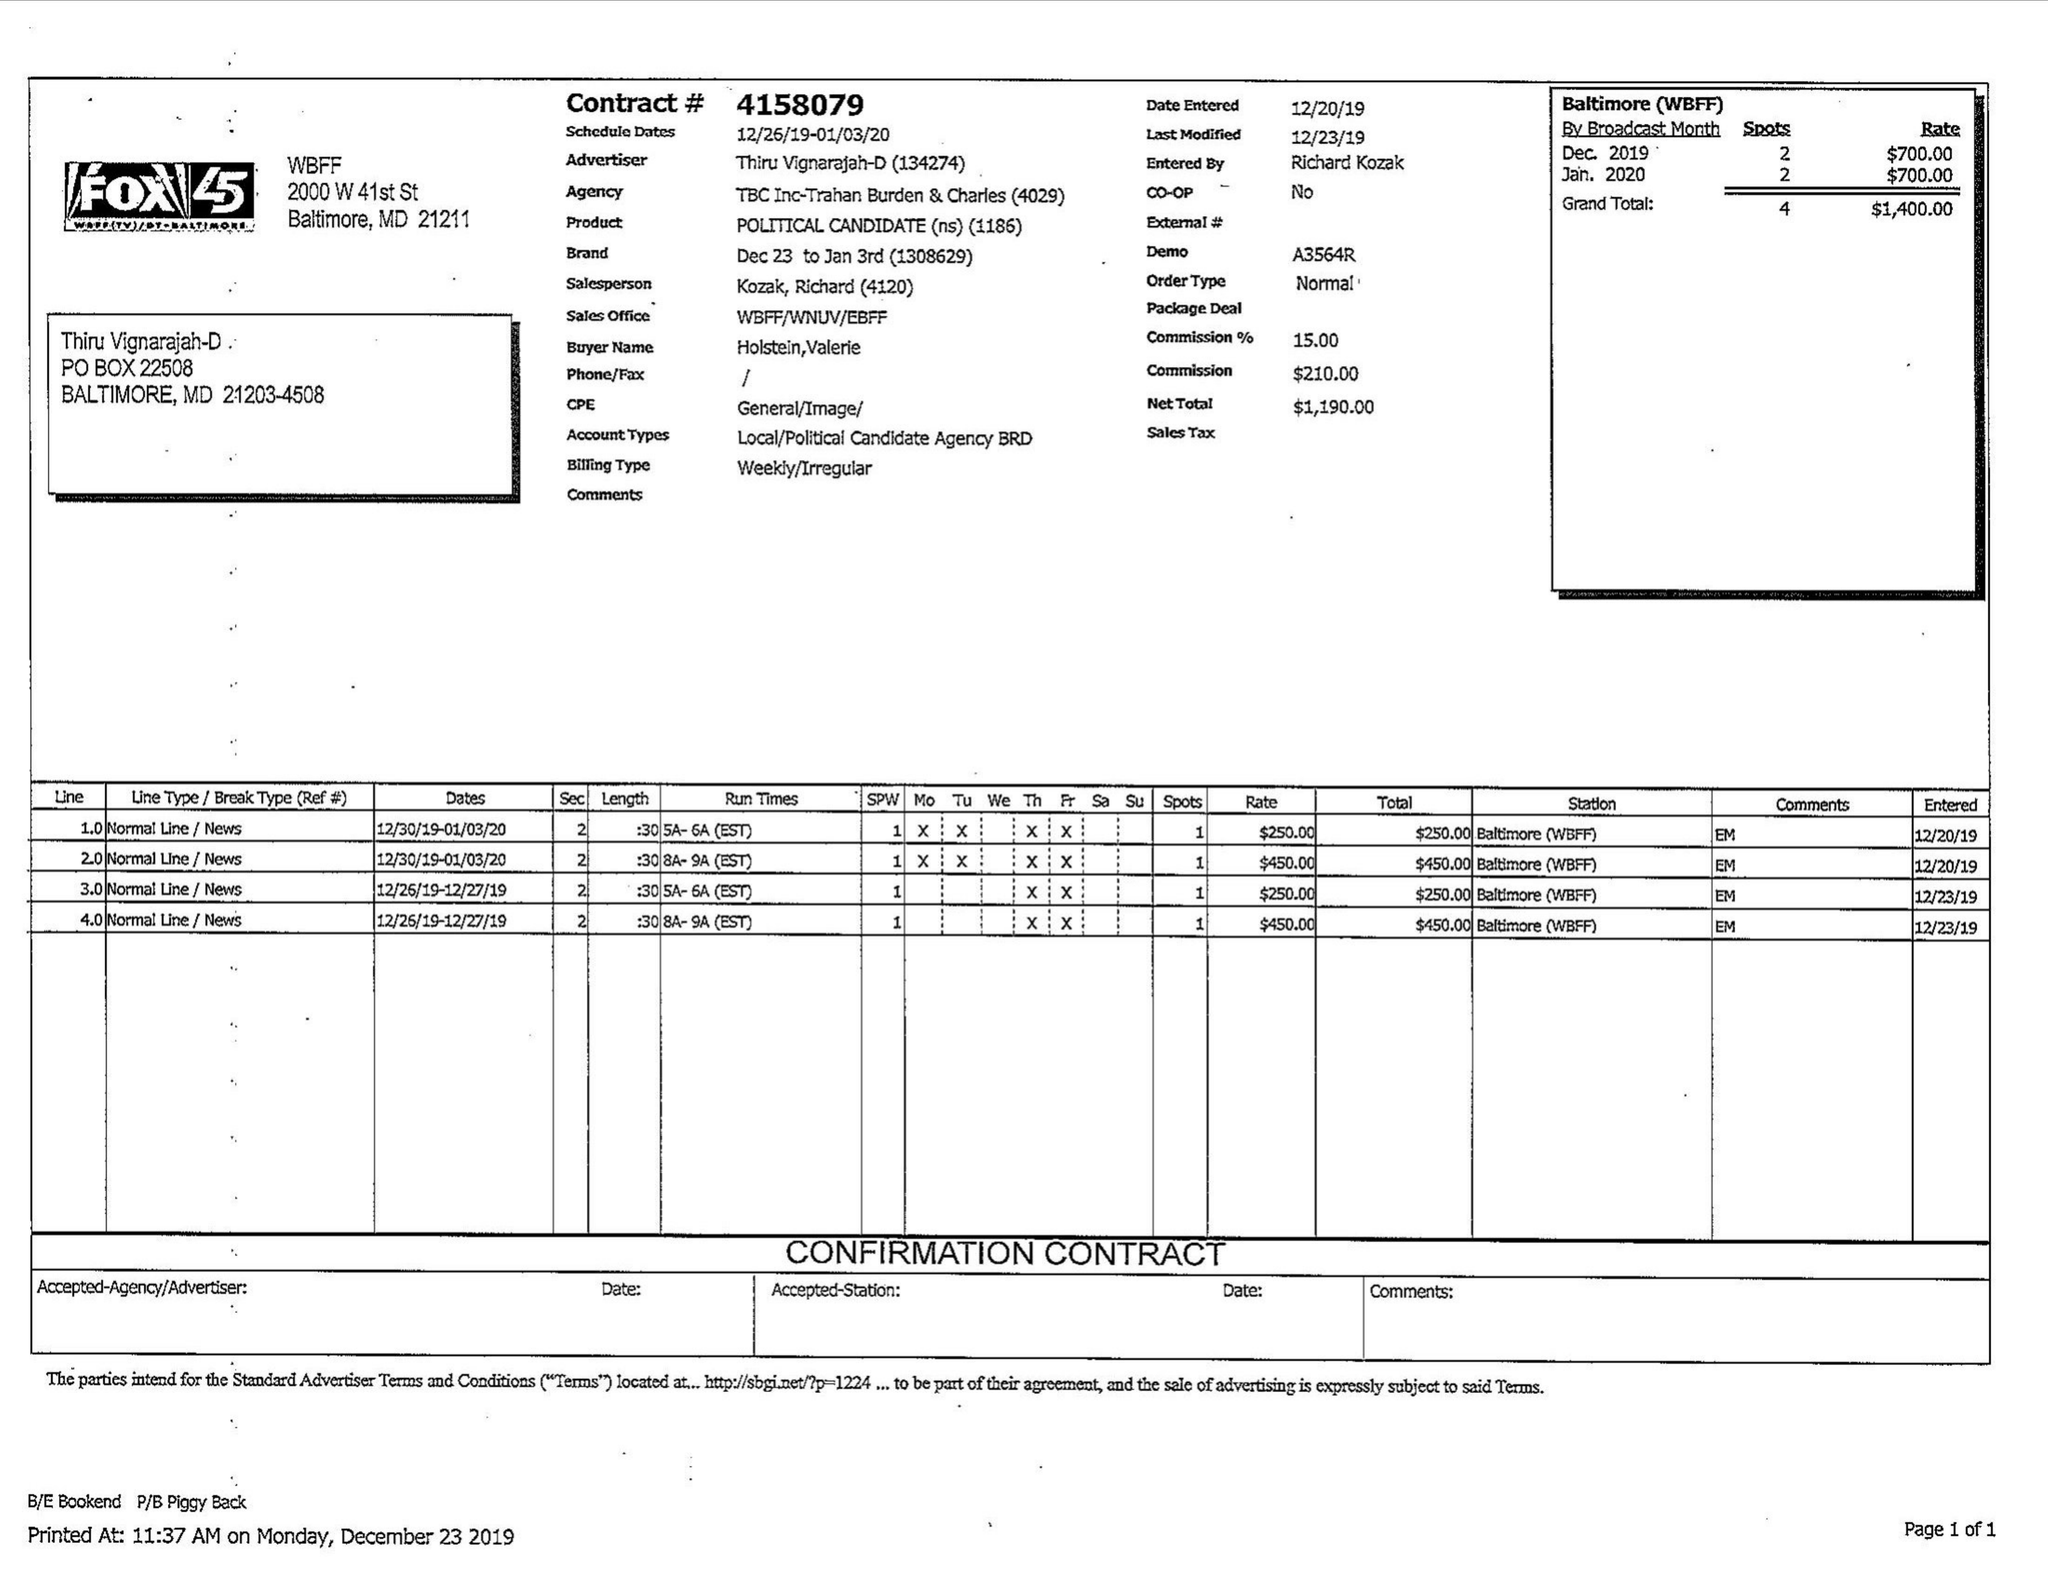What is the value for the advertiser?
Answer the question using a single word or phrase. THIRU VIGNARAJAH-D 